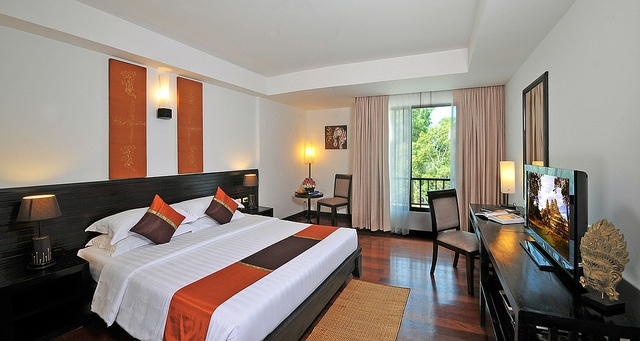Describe the objects in this image and their specific colors. I can see bed in darkgray, black, and lavender tones, tv in darkgray, black, lavender, gray, and maroon tones, chair in darkgray, black, and gray tones, chair in darkgray, black, gray, and maroon tones, and book in darkgray, lightgray, and tan tones in this image. 